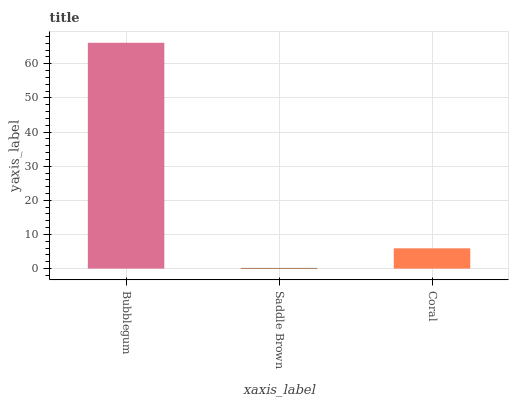Is Coral the minimum?
Answer yes or no. No. Is Coral the maximum?
Answer yes or no. No. Is Coral greater than Saddle Brown?
Answer yes or no. Yes. Is Saddle Brown less than Coral?
Answer yes or no. Yes. Is Saddle Brown greater than Coral?
Answer yes or no. No. Is Coral less than Saddle Brown?
Answer yes or no. No. Is Coral the high median?
Answer yes or no. Yes. Is Coral the low median?
Answer yes or no. Yes. Is Bubblegum the high median?
Answer yes or no. No. Is Bubblegum the low median?
Answer yes or no. No. 